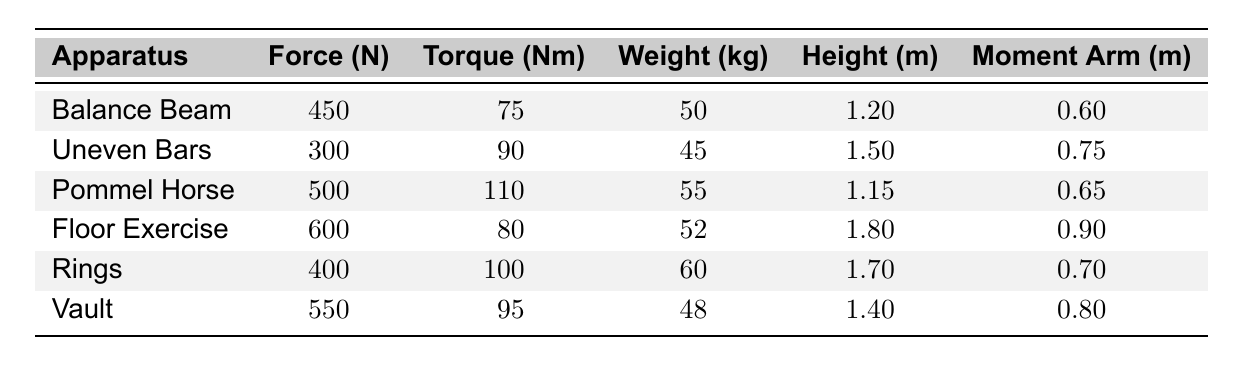What is the force applied on the Vault? From the table, the force for the Vault apparatus is listed as 550 N.
Answer: 550 N Which apparatus has the highest torque value? By looking at the Torque column, Pommel Horse has the highest value at 110 Nm.
Answer: Pommel Horse What is the average weight of the gymnasts across all apparatus? The total weight is (50 + 45 + 55 + 52 + 60 + 48) = 310 kg. There are 6 gymnasts, so the average weight is 310/6 = 51.67 kg.
Answer: 51.67 kg Is the force required for the Uneven Bars greater than 400 N? The force for the Uneven Bars is 300 N, which is less than 400 N, so the answer is no.
Answer: No What is the difference in torque between the Pommel Horse and Floor Exercise? The torque for Pommel Horse is 110 Nm and for Floor Exercise is 80 Nm. The difference is 110 - 80 = 30 Nm.
Answer: 30 Nm Which apparatus requires a greater moment arm, Rings or Vault? The moment arm for Rings is 0.7 m, and for Vault, it is 0.8 m. Since 0.8 is greater than 0.7, Vault requires a greater moment arm.
Answer: Vault What is the total force applied across all apparatus? The total force is calculated as (450 + 300 + 500 + 600 + 400 + 550) = 2800 N.
Answer: 2800 N Which gymnastic apparatus has a gymnastic weight closer to 50 kg? The Balance Beam has a weight of 50 kg, which is exactly 50 kg, making it the closest.
Answer: Balance Beam How does the torque of the Rings compare to that of the Balance Beam? The torque for Rings is 100 Nm, while for Balance Beam it is 75 Nm. Therefore, Rings has a greater torque by 100 - 75 = 25 Nm.
Answer: 25 Nm greater Which apparatus has the lowest force and what is that force? The Uneven Bars has the lowest force at 300 N.
Answer: Uneven Bars, 300 N 